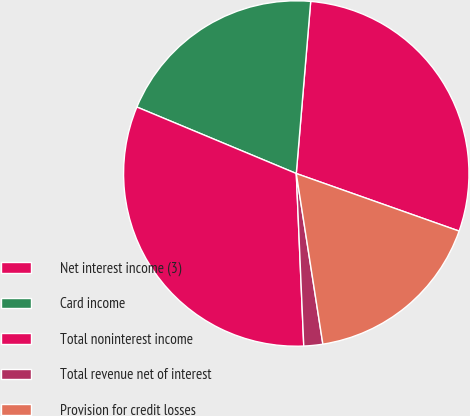<chart> <loc_0><loc_0><loc_500><loc_500><pie_chart><fcel>Net interest income (3)<fcel>Card income<fcel>Total noninterest income<fcel>Total revenue net of interest<fcel>Provision for credit losses<nl><fcel>29.08%<fcel>20.04%<fcel>31.98%<fcel>1.77%<fcel>17.13%<nl></chart> 